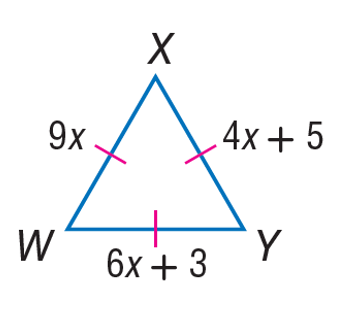Answer the mathemtical geometry problem and directly provide the correct option letter.
Question: Find the length of X Y.
Choices: A: 4 B: 5 C: 6 D: 9 D 